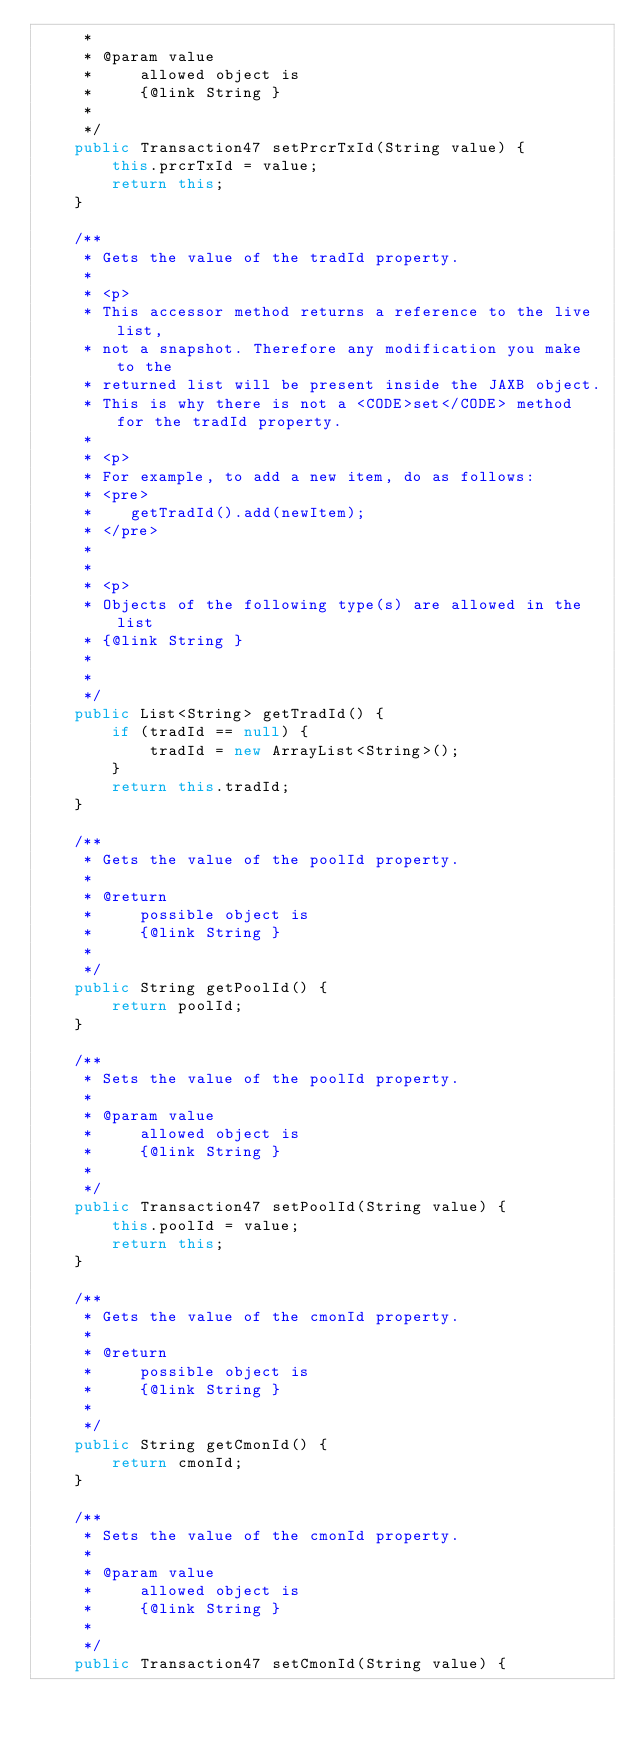<code> <loc_0><loc_0><loc_500><loc_500><_Java_>     * 
     * @param value
     *     allowed object is
     *     {@link String }
     *     
     */
    public Transaction47 setPrcrTxId(String value) {
        this.prcrTxId = value;
        return this;
    }

    /**
     * Gets the value of the tradId property.
     * 
     * <p>
     * This accessor method returns a reference to the live list,
     * not a snapshot. Therefore any modification you make to the
     * returned list will be present inside the JAXB object.
     * This is why there is not a <CODE>set</CODE> method for the tradId property.
     * 
     * <p>
     * For example, to add a new item, do as follows:
     * <pre>
     *    getTradId().add(newItem);
     * </pre>
     * 
     * 
     * <p>
     * Objects of the following type(s) are allowed in the list
     * {@link String }
     * 
     * 
     */
    public List<String> getTradId() {
        if (tradId == null) {
            tradId = new ArrayList<String>();
        }
        return this.tradId;
    }

    /**
     * Gets the value of the poolId property.
     * 
     * @return
     *     possible object is
     *     {@link String }
     *     
     */
    public String getPoolId() {
        return poolId;
    }

    /**
     * Sets the value of the poolId property.
     * 
     * @param value
     *     allowed object is
     *     {@link String }
     *     
     */
    public Transaction47 setPoolId(String value) {
        this.poolId = value;
        return this;
    }

    /**
     * Gets the value of the cmonId property.
     * 
     * @return
     *     possible object is
     *     {@link String }
     *     
     */
    public String getCmonId() {
        return cmonId;
    }

    /**
     * Sets the value of the cmonId property.
     * 
     * @param value
     *     allowed object is
     *     {@link String }
     *     
     */
    public Transaction47 setCmonId(String value) {</code> 